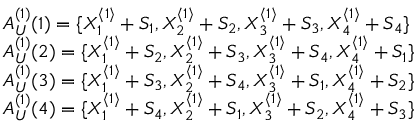Convert formula to latex. <formula><loc_0><loc_0><loc_500><loc_500>\begin{array} { r l } & { A _ { U } ^ { ( 1 ) } ( 1 ) = \{ X _ { 1 } ^ { \langle 1 \rangle } + S _ { 1 } , X _ { 2 } ^ { \langle 1 \rangle } + S _ { 2 } , X _ { 3 } ^ { \langle 1 \rangle } + S _ { 3 } , X _ { 4 } ^ { \langle 1 \rangle } + S _ { 4 } \} } \\ & { A _ { U } ^ { ( 1 ) } ( 2 ) = \{ X _ { 1 } ^ { \langle 1 \rangle } + S _ { 2 } , X _ { 2 } ^ { \langle 1 \rangle } + S _ { 3 } , X _ { 3 } ^ { \langle 1 \rangle } + S _ { 4 } , X _ { 4 } ^ { \langle 1 \rangle } + S _ { 1 } \} } \\ & { A _ { U } ^ { ( 1 ) } ( 3 ) = \{ X _ { 1 } ^ { \langle 1 \rangle } + S _ { 3 } , X _ { 2 } ^ { \langle 1 \rangle } + S _ { 4 } , X _ { 3 } ^ { \langle 1 \rangle } + S _ { 1 } , X _ { 4 } ^ { \langle 1 \rangle } + S _ { 2 } \} } \\ & { A _ { U } ^ { ( 1 ) } ( 4 ) = \{ X _ { 1 } ^ { \langle 1 \rangle } + S _ { 4 } , X _ { 2 } ^ { \langle 1 \rangle } + S _ { 1 } , X _ { 3 } ^ { \langle 1 \rangle } + S _ { 2 } , X _ { 4 } ^ { \langle 1 \rangle } + S _ { 3 } \} } \end{array}</formula> 